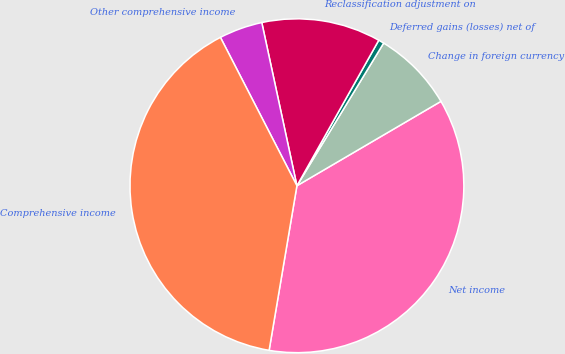<chart> <loc_0><loc_0><loc_500><loc_500><pie_chart><fcel>Net income<fcel>Change in foreign currency<fcel>Deferred gains (losses) net of<fcel>Reclassification adjustment on<fcel>Other comprehensive income<fcel>Comprehensive income<nl><fcel>36.1%<fcel>7.87%<fcel>0.54%<fcel>11.53%<fcel>4.2%<fcel>39.76%<nl></chart> 